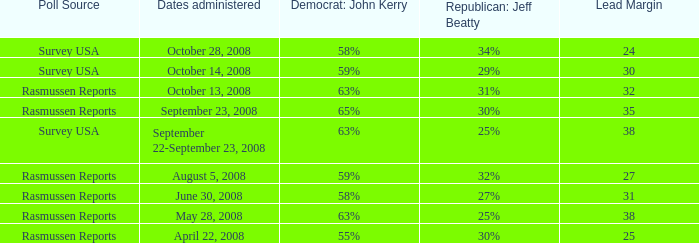What is the percentage for john kerry and dates administered is april 22, 2008? 55%. 